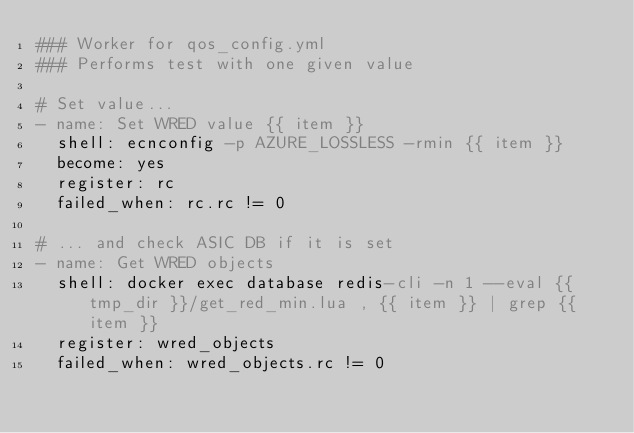Convert code to text. <code><loc_0><loc_0><loc_500><loc_500><_YAML_>### Worker for qos_config.yml
### Performs test with one given value

# Set value...
- name: Set WRED value {{ item }}
  shell: ecnconfig -p AZURE_LOSSLESS -rmin {{ item }}
  become: yes
  register: rc
  failed_when: rc.rc != 0

# ... and check ASIC DB if it is set
- name: Get WRED objects
  shell: docker exec database redis-cli -n 1 --eval {{ tmp_dir }}/get_red_min.lua , {{ item }} | grep {{ item }}
  register: wred_objects
  failed_when: wred_objects.rc != 0

</code> 